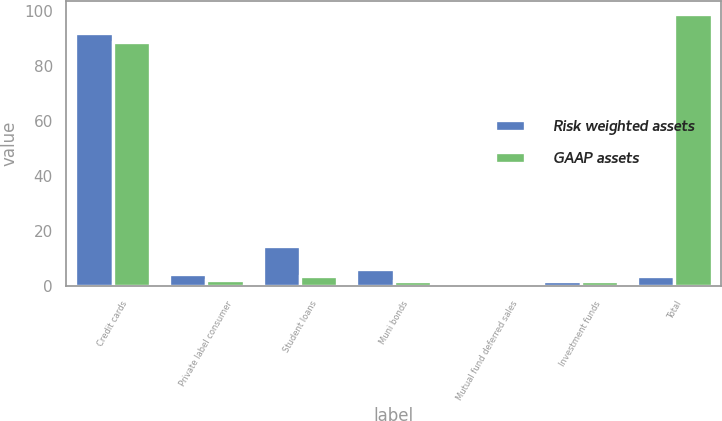Convert chart to OTSL. <chart><loc_0><loc_0><loc_500><loc_500><stacked_bar_chart><ecel><fcel>Credit cards<fcel>Private label consumer<fcel>Student loans<fcel>Muni bonds<fcel>Mutual fund deferred sales<fcel>Investment funds<fcel>Total<nl><fcel>Risk weighted assets<fcel>91.9<fcel>4.4<fcel>14.4<fcel>6.2<fcel>0.8<fcel>1.7<fcel>3.5<nl><fcel>GAAP assets<fcel>88.9<fcel>2.1<fcel>3.5<fcel>1.9<fcel>0.8<fcel>1.7<fcel>98.9<nl></chart> 